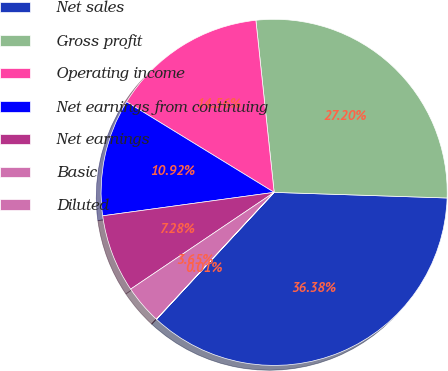Convert chart. <chart><loc_0><loc_0><loc_500><loc_500><pie_chart><fcel>Net sales<fcel>Gross profit<fcel>Operating income<fcel>Net earnings from continuing<fcel>Net earnings<fcel>Basic<fcel>Diluted<nl><fcel>36.38%<fcel>27.2%<fcel>14.56%<fcel>10.92%<fcel>7.28%<fcel>3.65%<fcel>0.01%<nl></chart> 